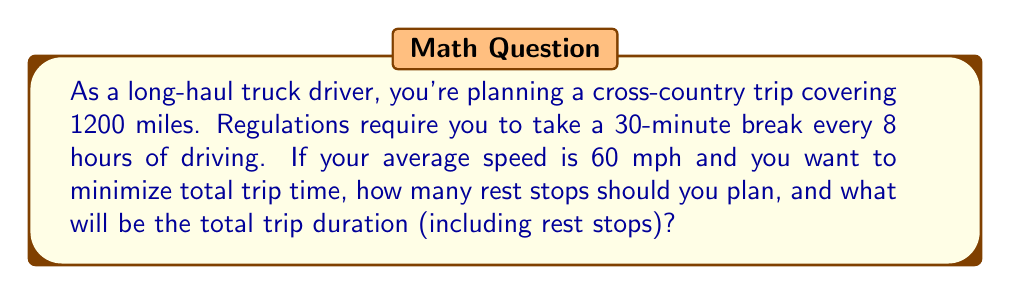Show me your answer to this math problem. Let's approach this step-by-step:

1) First, calculate the total driving time without stops:
   $$\text{Driving time} = \frac{\text{Total distance}}{\text{Average speed}} = \frac{1200 \text{ miles}}{60 \text{ mph}} = 20 \text{ hours}$$

2) Now, let's consider the rest stops. We need to find how many 8-hour driving segments fit into 20 hours:
   $$\text{Number of full 8-hour segments} = \left\lfloor\frac{20 \text{ hours}}{8 \text{ hours}}\right\rfloor = 2$$
   
   This means we'll have 2 rest stops, with some driving time left over.

3) Calculate the remaining driving time:
   $$\text{Remaining time} = 20 \text{ hours} - (2 \times 8 \text{ hours}) = 4 \text{ hours}$$

4) Each rest stop adds 0.5 hours (30 minutes) to the trip. So the total added time is:
   $$\text{Rest time} = 2 \times 0.5 \text{ hours} = 1 \text{ hour}$$

5) Calculate the total trip duration:
   $$\text{Total trip time} = \text{Driving time} + \text{Rest time} = 20 \text{ hours} + 1 \text{ hour} = 21 \text{ hours}$$

Therefore, you should plan for 2 rest stops, and the total trip duration will be 21 hours.
Answer: 2 rest stops; 21 hours total trip duration 